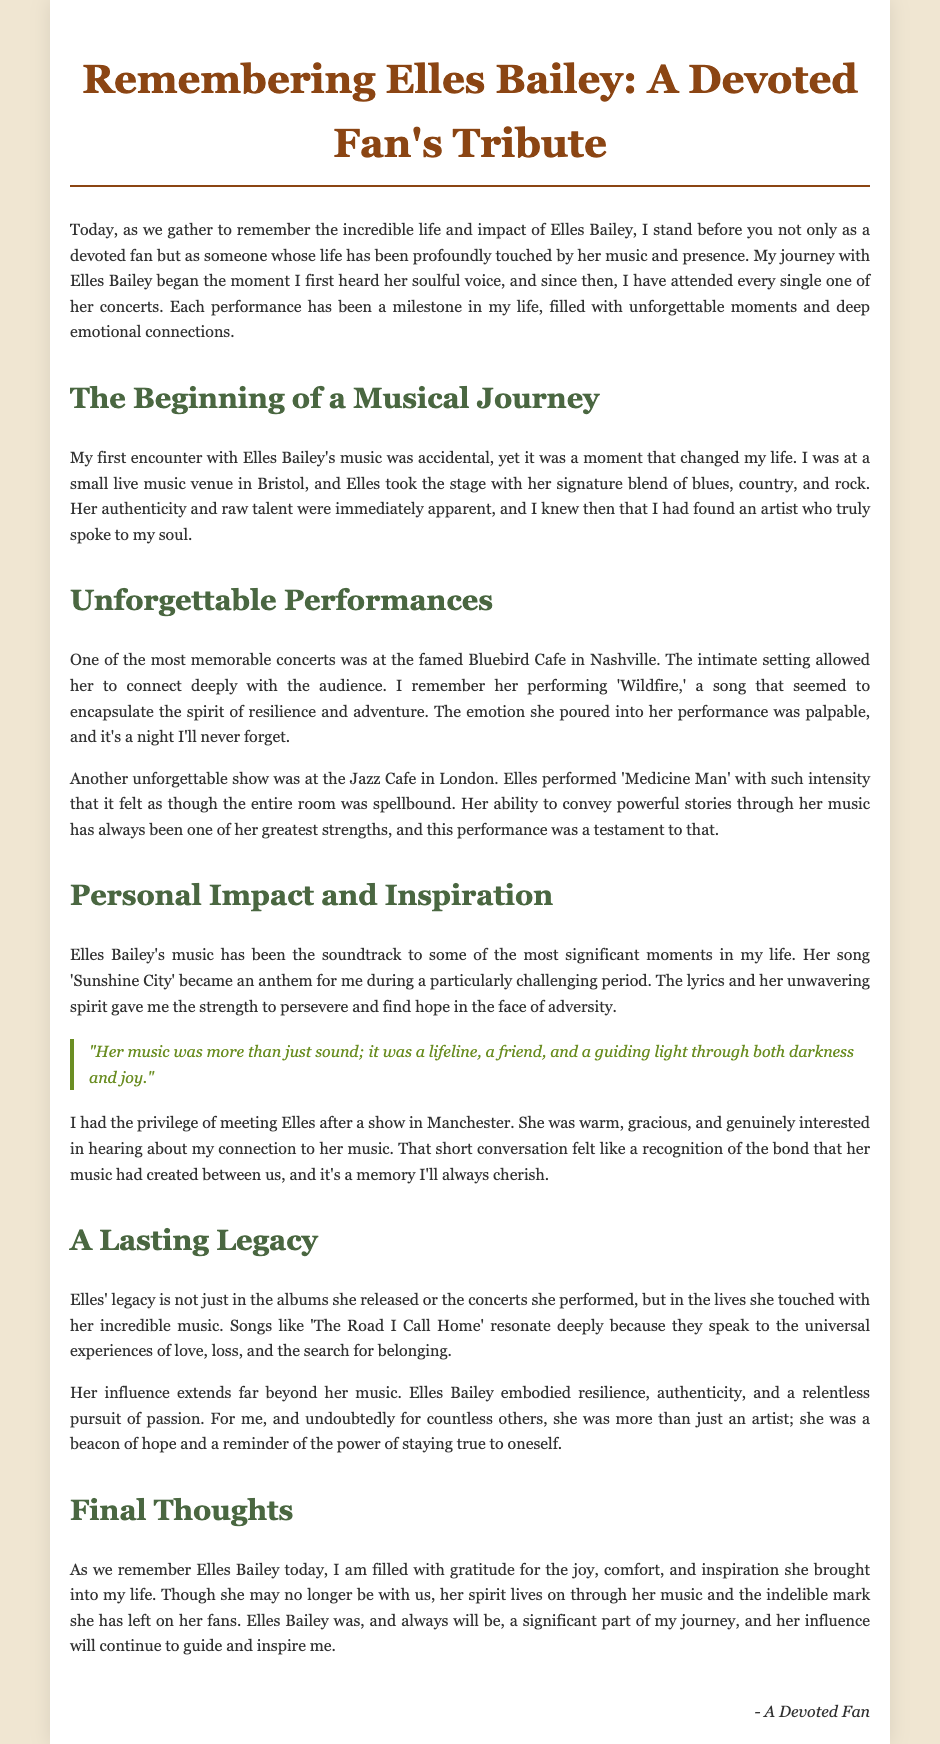What was the first venue where the speaker encountered Elles Bailey's music? The speaker first heard Elles Bailey's music at a small live music venue in Bristol.
Answer: Bristol Which song performed at the Bluebird Cafe encapsulated the spirit of resilience? The song 'Wildfire' performed at the Bluebird Cafe is mentioned as encapsulating the spirit of resilience.
Answer: Wildfire What was the signature blend of music styles used by Elles Bailey? The document states that her signature blend includes blues, country, and rock.
Answer: Blues, country, and rock Who did the speaker meet after a show in Manchester? The speaker had the privilege of meeting Elles Bailey after a show in Manchester.
Answer: Elles Bailey What type of legacy did Elles Bailey leave behind according to the speaker? The legacy of Elles Bailey is described as touching lives with incredible music and embodying resilience and authenticity.
Answer: Touching lives with incredible music What phrase describes how the speaker felt about Elles Bailey's music during challenging times? The speaker refers to the music as an anthem during a challenging period, specifically mentioning her song 'Sunshine City.'
Answer: Anthem during a challenging period Which concert location is described as more intimate? The concert at the Jazz Cafe in London is described as having an intense atmosphere where the audience was spellbound.
Answer: Jazz Cafe in London What did the speaker feel after attending every concert by Elles Bailey? The speaker expresses that each performance has been a milestone filled with unforgettable moments.
Answer: Unforgettable moments What is the last section of the eulogy titled? The final section is titled "Final Thoughts."
Answer: Final Thoughts 